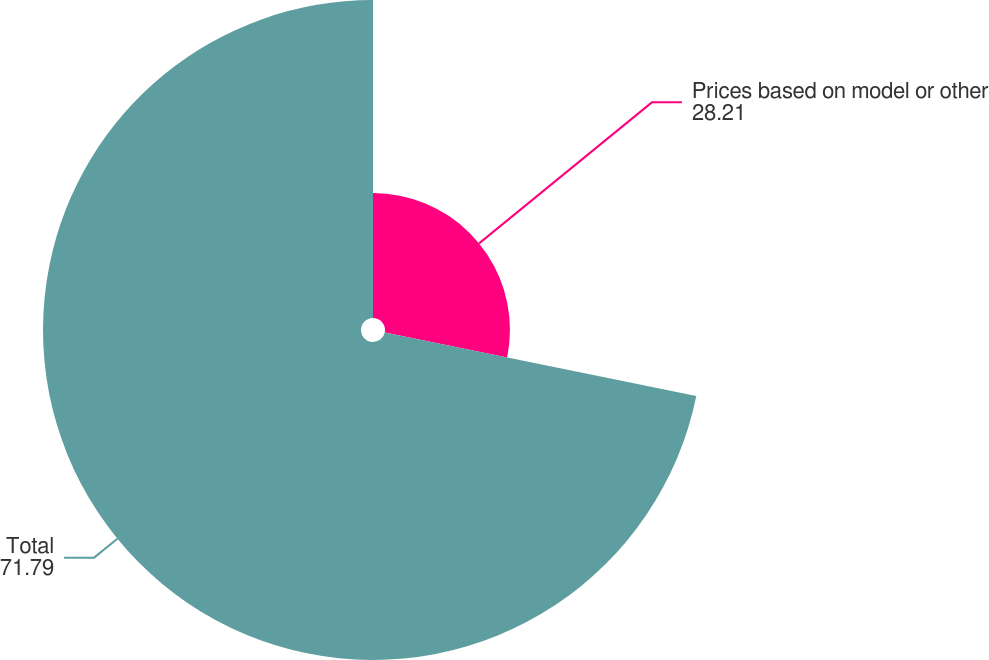Convert chart. <chart><loc_0><loc_0><loc_500><loc_500><pie_chart><fcel>Prices based on model or other<fcel>Total<nl><fcel>28.21%<fcel>71.79%<nl></chart> 